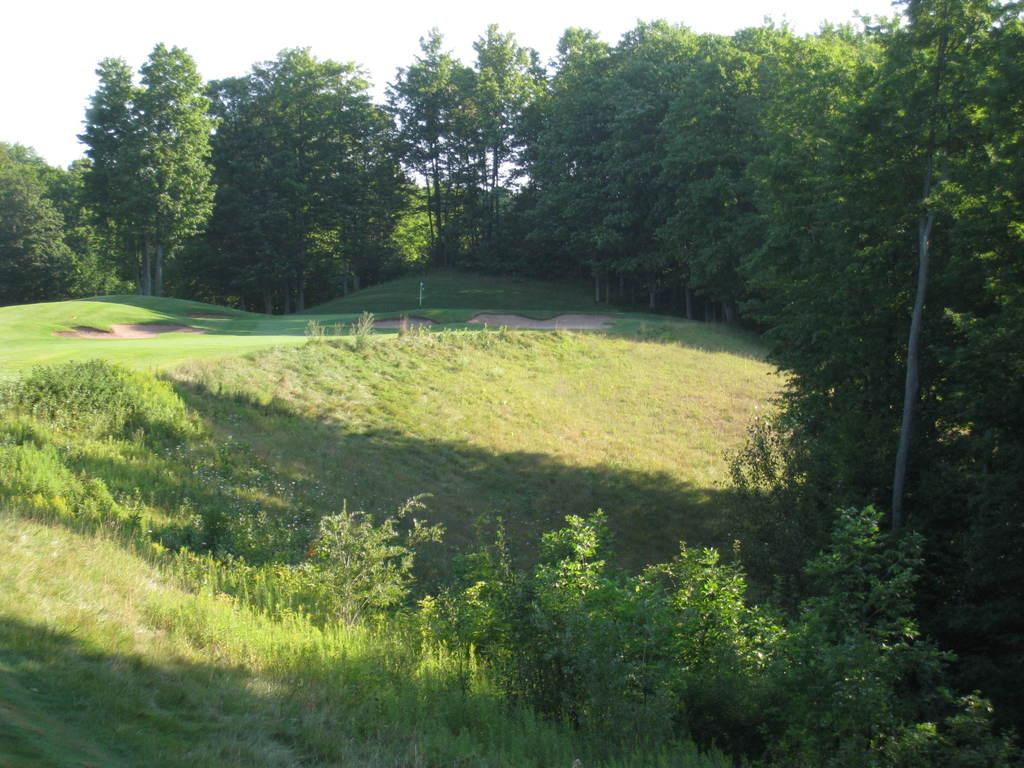Where was the picture taken? The picture was clicked outside. What can be seen in the foreground of the image? There are plants and green grass in the foreground. What is visible in the background of the image? The sky and trees are visible in the background. What type of toys can be seen scattered on the route in the image? There are no toys or routes present in the image; it features plants, green grass, sky, and trees. 